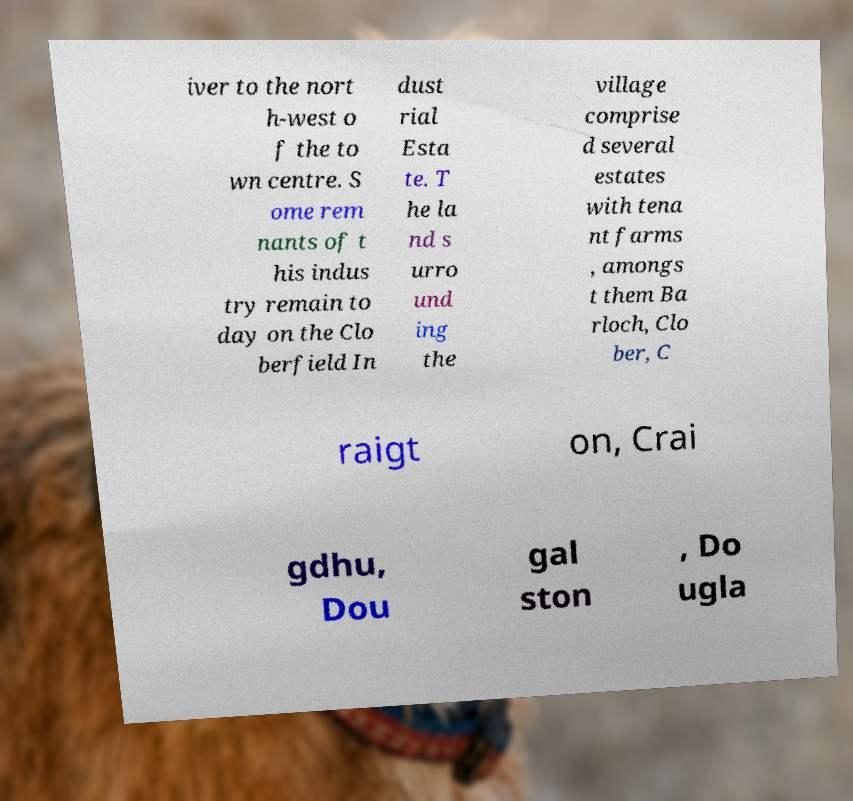Could you extract and type out the text from this image? iver to the nort h-west o f the to wn centre. S ome rem nants of t his indus try remain to day on the Clo berfield In dust rial Esta te. T he la nd s urro und ing the village comprise d several estates with tena nt farms , amongs t them Ba rloch, Clo ber, C raigt on, Crai gdhu, Dou gal ston , Do ugla 